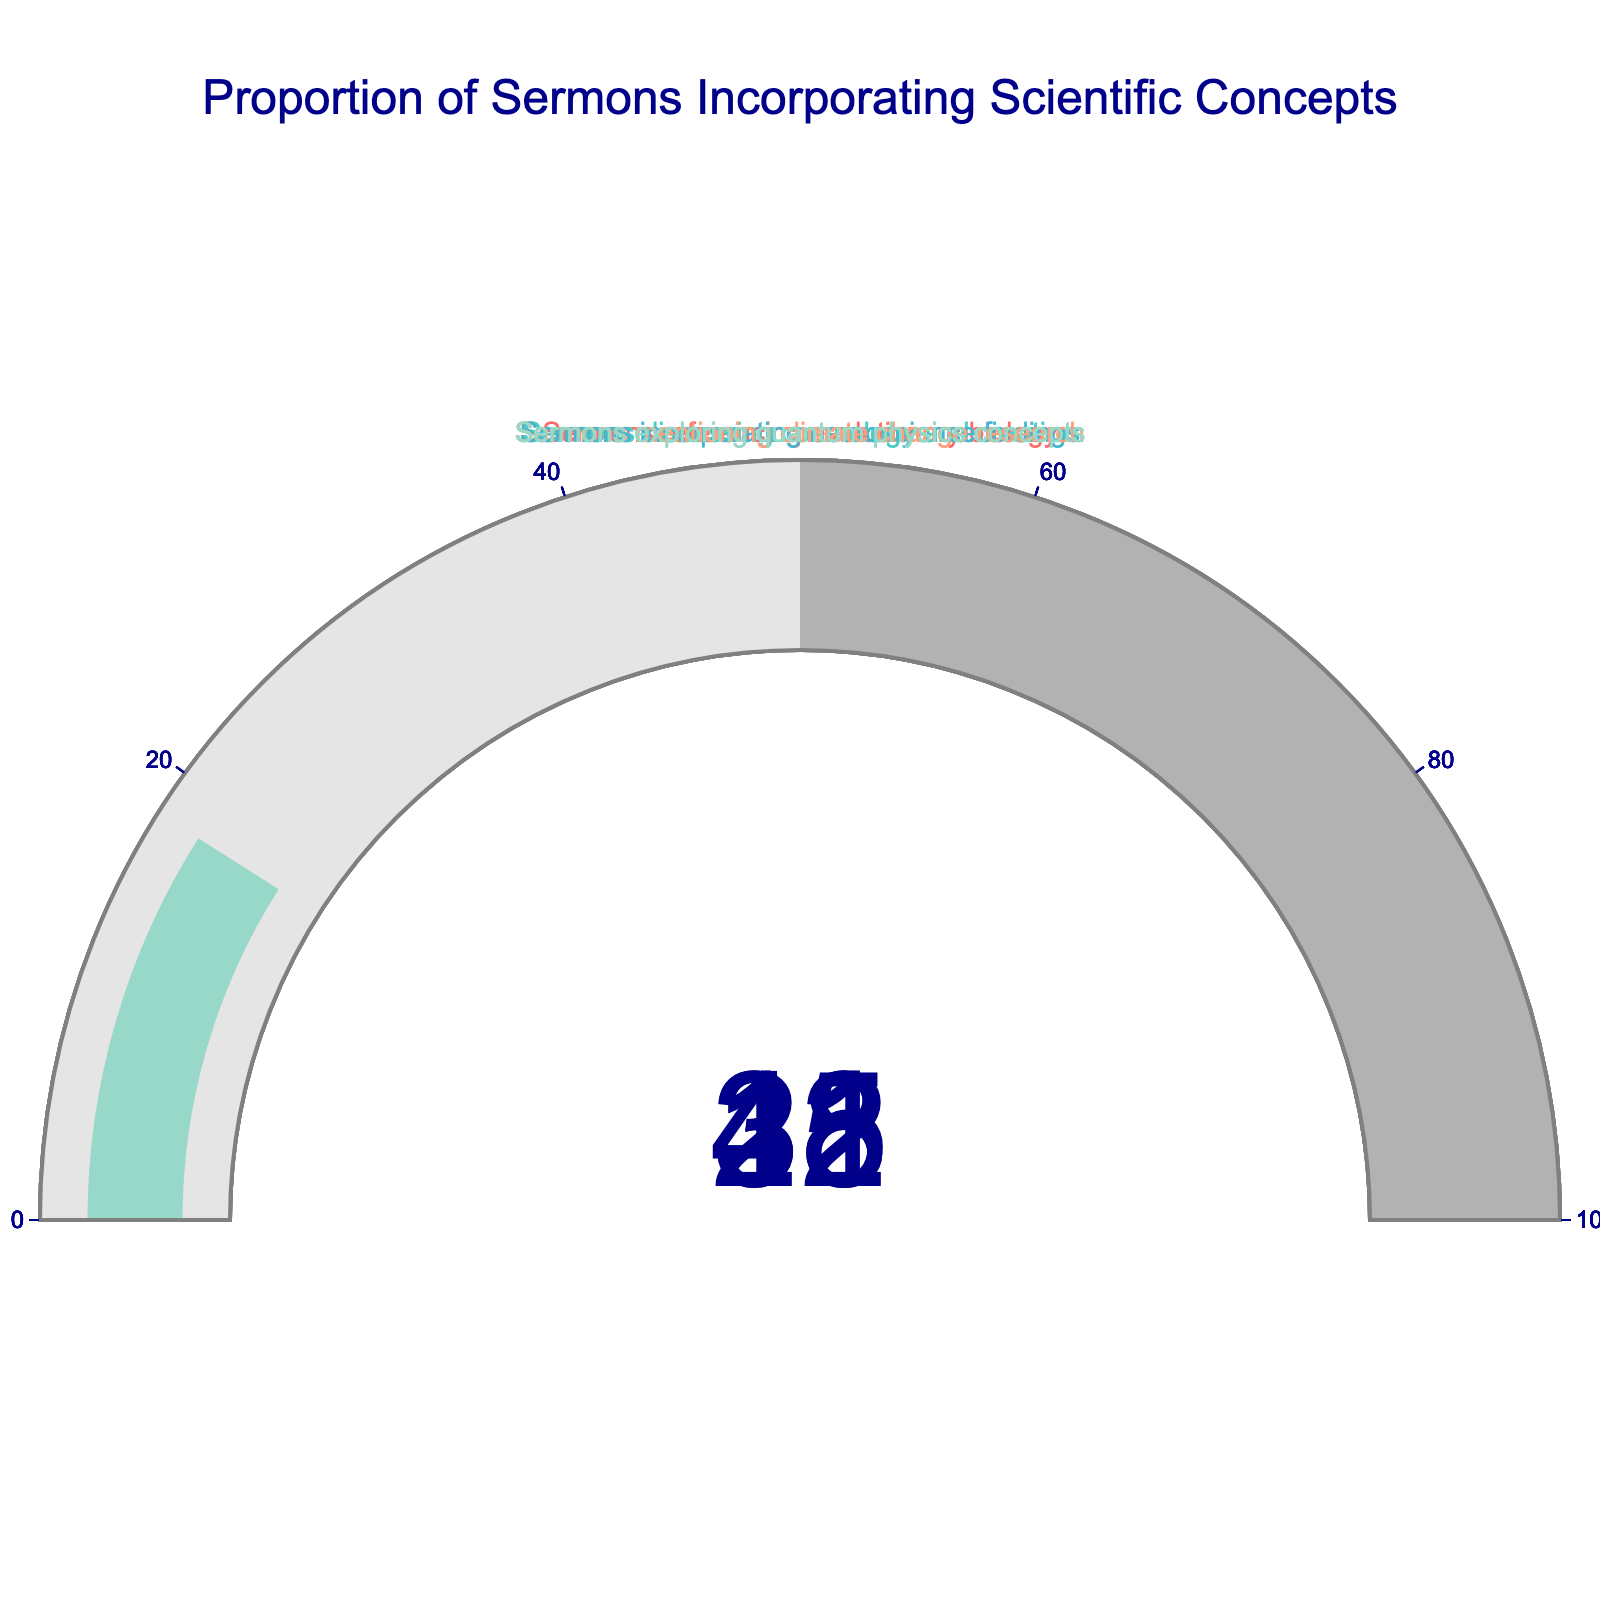What is the title of the figure? The figure displays a title at the top. By reading it, we can identify the title as "Proportion of Sermons Incorporating Scientific Concepts."
Answer: Proportion of Sermons Incorporating Scientific Concepts How many different scientific topics are referenced in the figure? We can count the number of gauge charts present, which correspond to the different scientific topics being referenced. There are five distinct topics listed in the figure: evolutionary biology, cosmology and creation, neuroscience findings, climate change research, and quantum physics concepts.
Answer: Five Which scientific topic has the highest percentage of sermons referencing it? We look at the values displayed on each gauge chart. The highest value reported is 42%, which corresponds to the topic of cosmology and creation.
Answer: Cosmology and creation What is the combined percentage of sermons referencing evolutionary biology and climate change research? We find the percentages for evolutionary biology (35%) and climate change research (31%). Adding these values together gives us 35 + 31 = 66.
Answer: 66% Is there any topic whose percentage of sermons referencing it is less than 20%? We review the values for each gauge chart: evolutionary biology (35%), cosmology and creation (42%), neuroscience findings (28%), climate change research (31%), and quantum physics concepts (18%). Only quantum physics concepts have a percentage of less than 20%.
Answer: Yes, quantum physics concepts How much greater is the proportion of sermons incorporating neuroscience findings than those incorporating quantum physics concepts? Neuroscience findings have a percentage of 28% and quantum physics concepts have 18%. The difference is computed as 28 - 18 = 10.
Answer: 10% Are there more sermons discussing cosmology and creation than those mentioning climate change research? Comparing the percentages, cosmology and creation have 42%, whereas climate change research has 31%. Since 42% is greater than 31%, the answer is yes.
Answer: Yes What is the average percentage of sermons that incorporate scientific concepts, based on the listed topics? We calculate the average by summing all percentage values and dividing by the number of topics: (35 + 42 + 28 + 31 + 18) / 5. The total sum is 154, and dividing by 5 gives an average of 30.8%.
Answer: 30.8% If the topics were ranked from most referenced in sermons to least referenced, what position does the topic of climate change research hold? We can rank the percentages from highest to lowest: 42% (cosmology and creation), 35% (evolutionary biology), 31% (climate change research), 28% (neuroscience findings), 18% (quantum physics concepts). Climate change research is in the 3rd position.
Answer: Third 